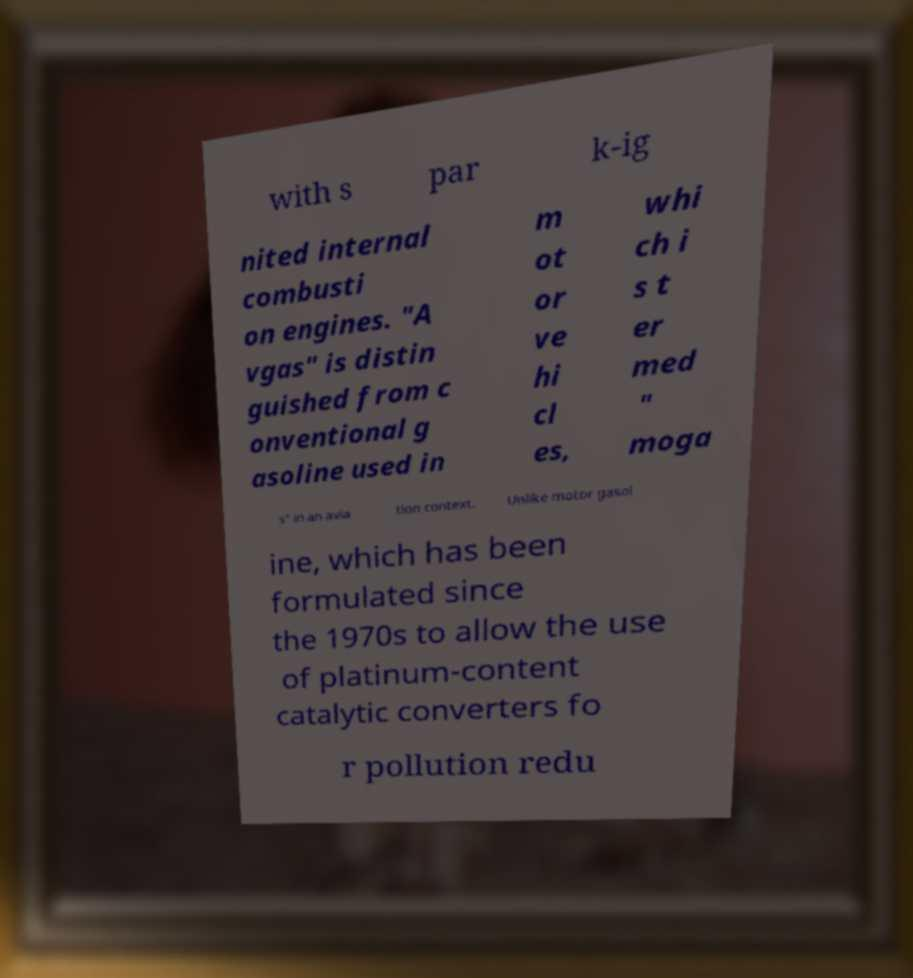What messages or text are displayed in this image? I need them in a readable, typed format. with s par k-ig nited internal combusti on engines. "A vgas" is distin guished from c onventional g asoline used in m ot or ve hi cl es, whi ch i s t er med " moga s" in an avia tion context. Unlike motor gasol ine, which has been formulated since the 1970s to allow the use of platinum-content catalytic converters fo r pollution redu 